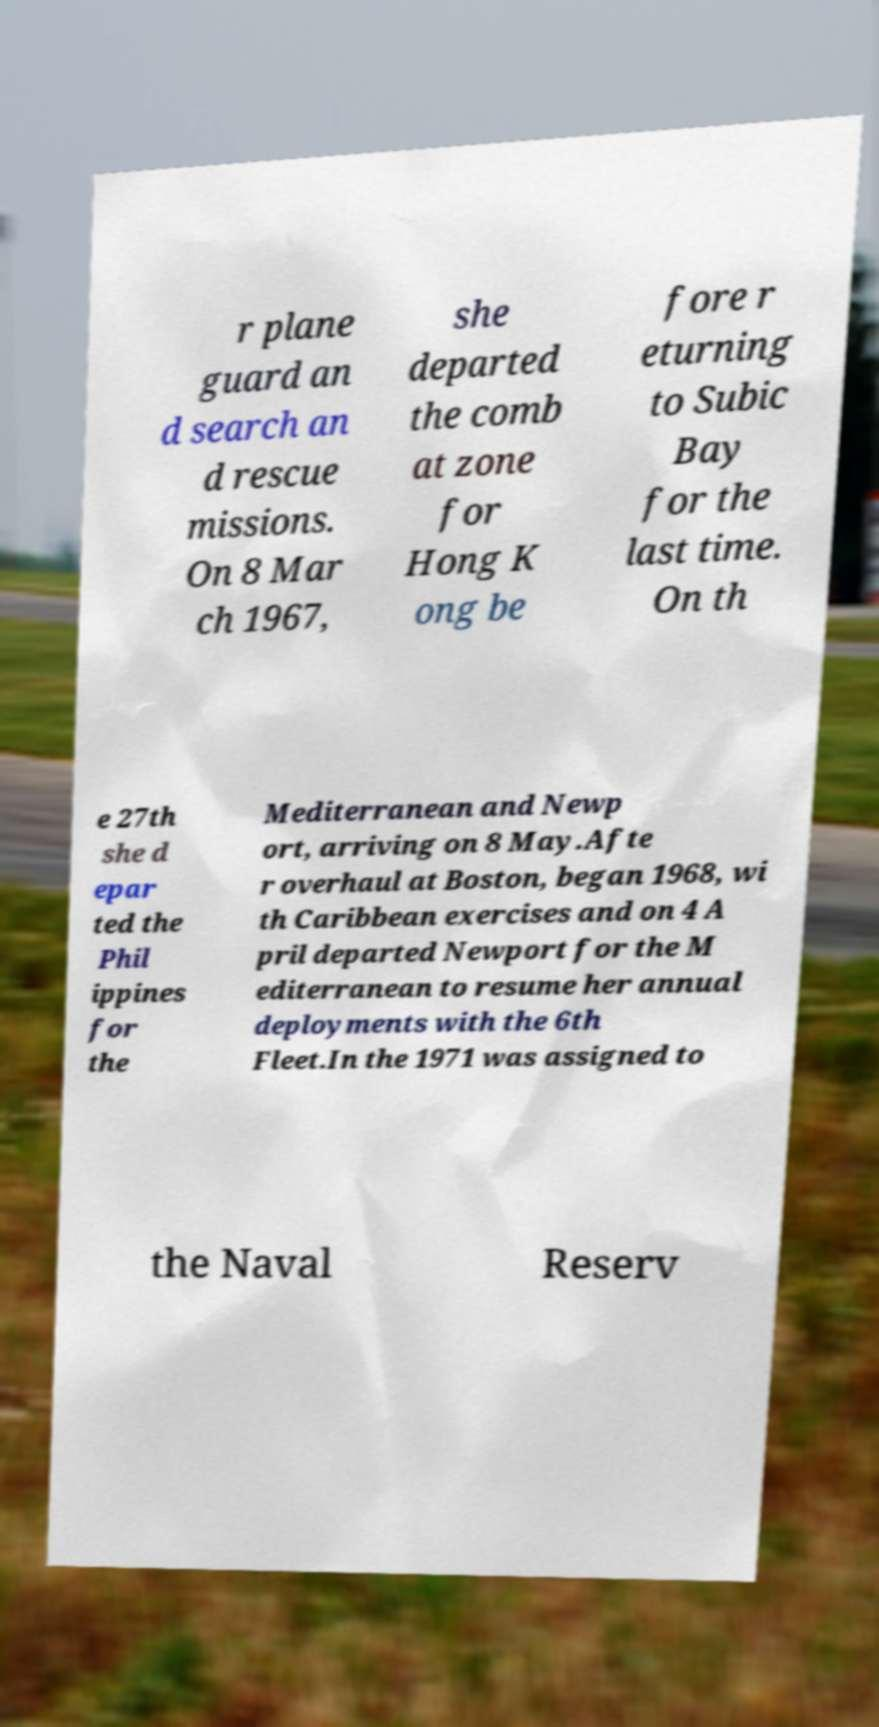Can you read and provide the text displayed in the image?This photo seems to have some interesting text. Can you extract and type it out for me? r plane guard an d search an d rescue missions. On 8 Mar ch 1967, she departed the comb at zone for Hong K ong be fore r eturning to Subic Bay for the last time. On th e 27th she d epar ted the Phil ippines for the Mediterranean and Newp ort, arriving on 8 May.Afte r overhaul at Boston, began 1968, wi th Caribbean exercises and on 4 A pril departed Newport for the M editerranean to resume her annual deployments with the 6th Fleet.In the 1971 was assigned to the Naval Reserv 